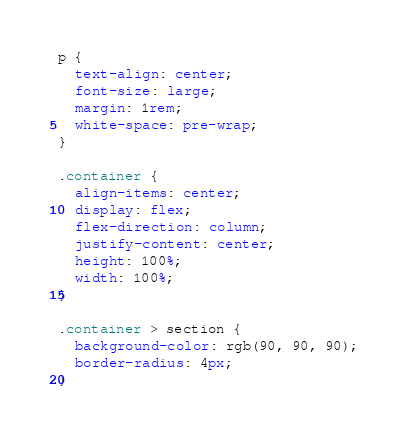Convert code to text. <code><loc_0><loc_0><loc_500><loc_500><_CSS_>p {
  text-align: center;
  font-size: large;
  margin: 1rem;
  white-space: pre-wrap;
}

.container {
  align-items: center;
  display: flex;
  flex-direction: column;
  justify-content: center;
  height: 100%;
  width: 100%;
}

.container > section {
  background-color: rgb(90, 90, 90);
  border-radius: 4px;
}
</code> 